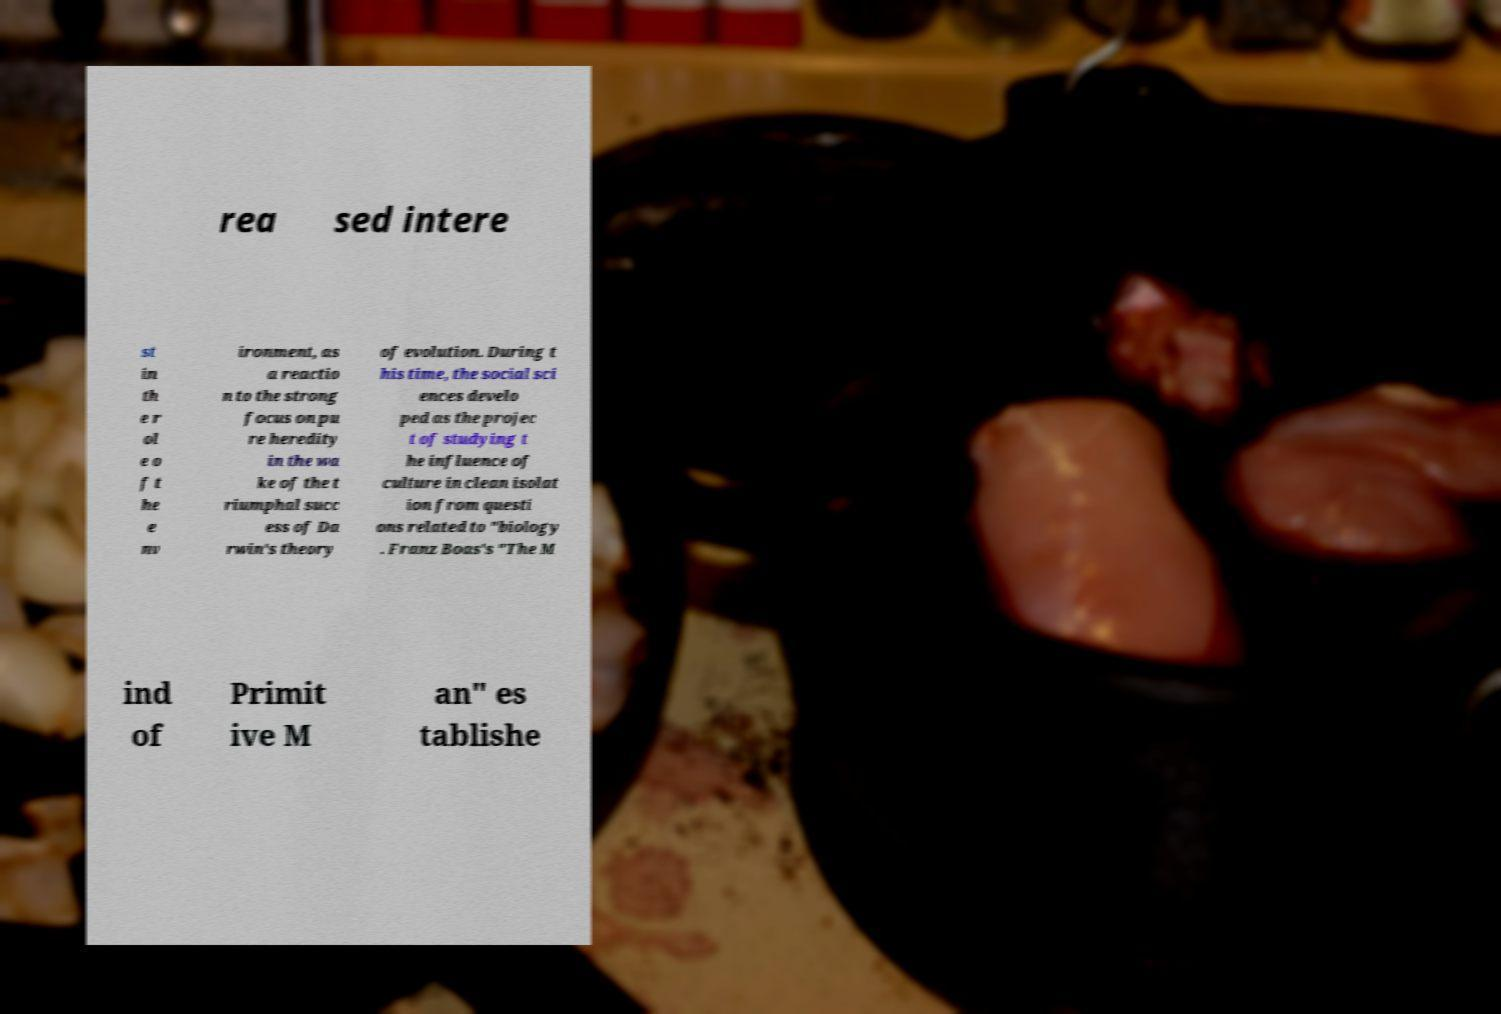What messages or text are displayed in this image? I need them in a readable, typed format. rea sed intere st in th e r ol e o f t he e nv ironment, as a reactio n to the strong focus on pu re heredity in the wa ke of the t riumphal succ ess of Da rwin's theory of evolution. During t his time, the social sci ences develo ped as the projec t of studying t he influence of culture in clean isolat ion from questi ons related to "biology . Franz Boas's "The M ind of Primit ive M an" es tablishe 